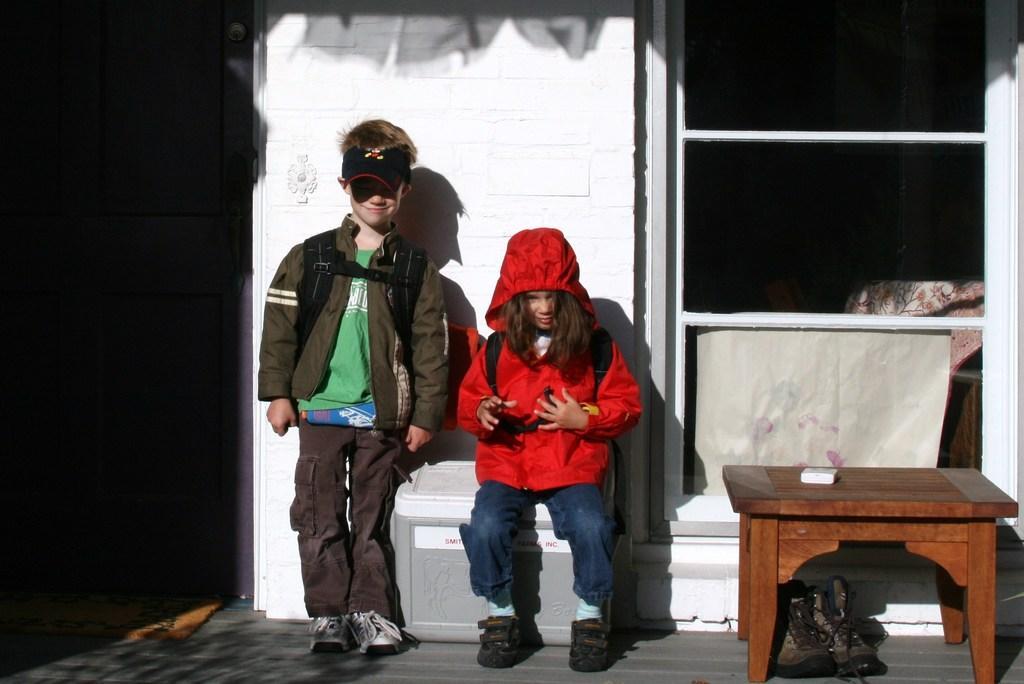Please provide a concise description of this image. In this image we can see a girl is sitting and a boy is standing, and here is the table, and at side here is the door, and here is the wall, and here is the window. 